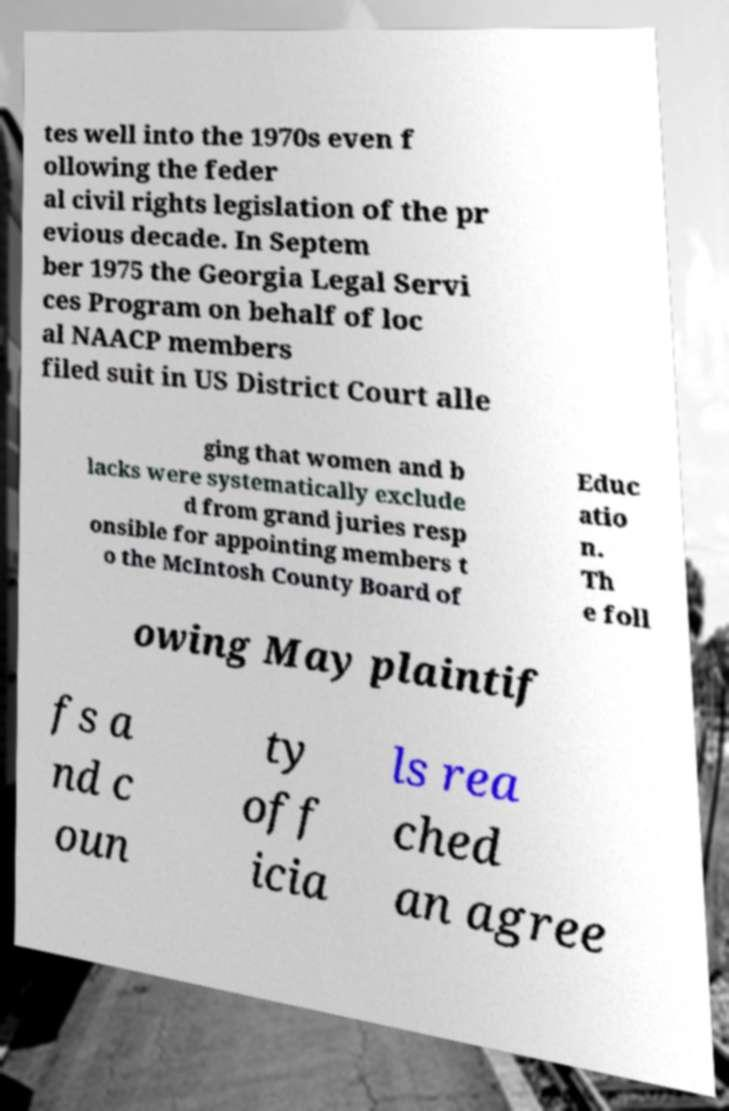Could you assist in decoding the text presented in this image and type it out clearly? tes well into the 1970s even f ollowing the feder al civil rights legislation of the pr evious decade. In Septem ber 1975 the Georgia Legal Servi ces Program on behalf of loc al NAACP members filed suit in US District Court alle ging that women and b lacks were systematically exclude d from grand juries resp onsible for appointing members t o the McIntosh County Board of Educ atio n. Th e foll owing May plaintif fs a nd c oun ty off icia ls rea ched an agree 